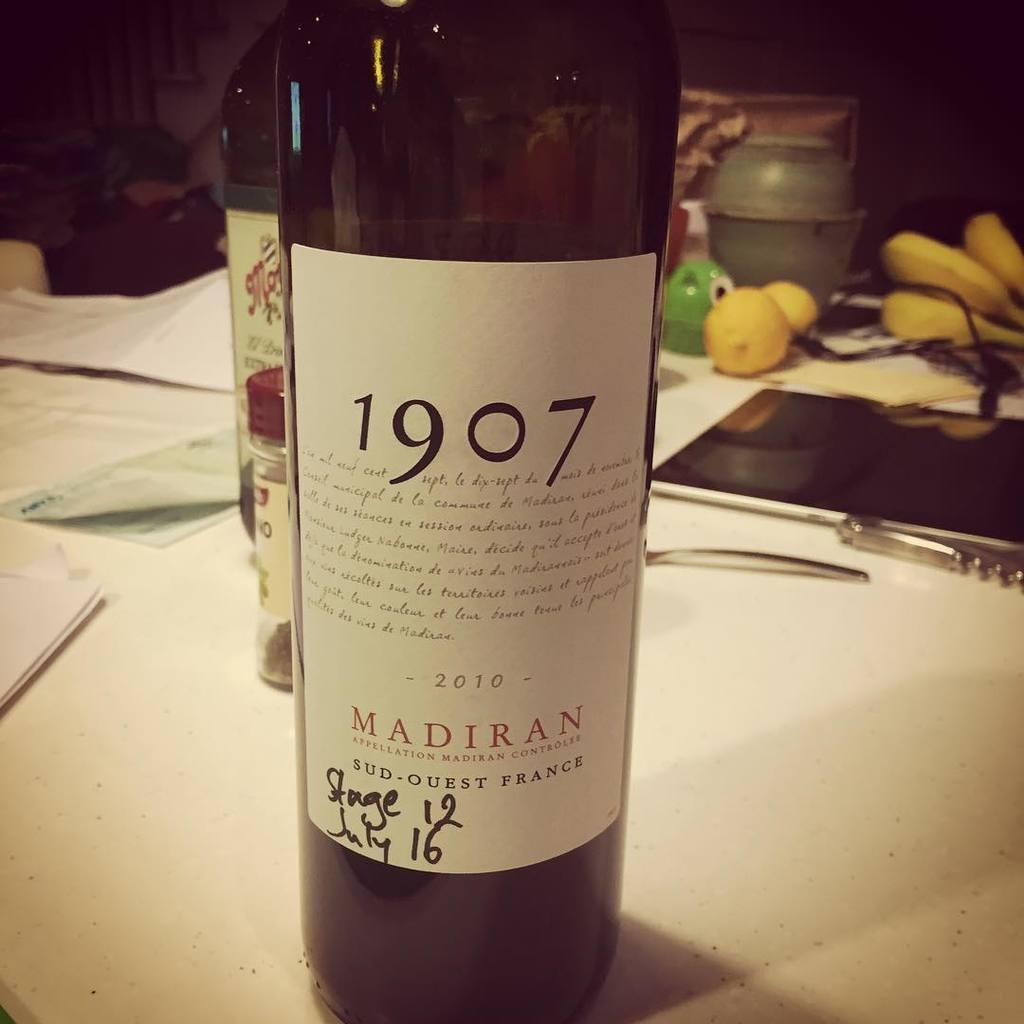How many bottles are visible in the image? There are two bottles in the image. What is written on the labels of the bottles? The bottles are labelled as "MADIRAN 1907". Where are the bottles placed in the image? The bottles are placed on a table. What other items can be seen on the table? There are papers, mobile devices, fruits, and a jar on the table. What historical event is being celebrated in the image? There is no indication of a historical event being celebrated in the image. What type of club is associated with the bottles in the image? There is no club associated with the bottles in the image. 